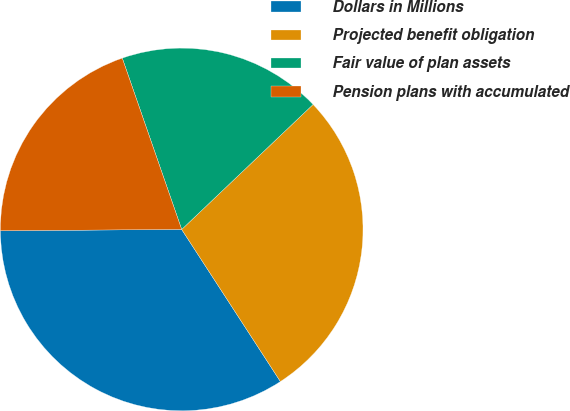Convert chart to OTSL. <chart><loc_0><loc_0><loc_500><loc_500><pie_chart><fcel>Dollars in Millions<fcel>Projected benefit obligation<fcel>Fair value of plan assets<fcel>Pension plans with accumulated<nl><fcel>34.05%<fcel>27.94%<fcel>18.21%<fcel>19.8%<nl></chart> 